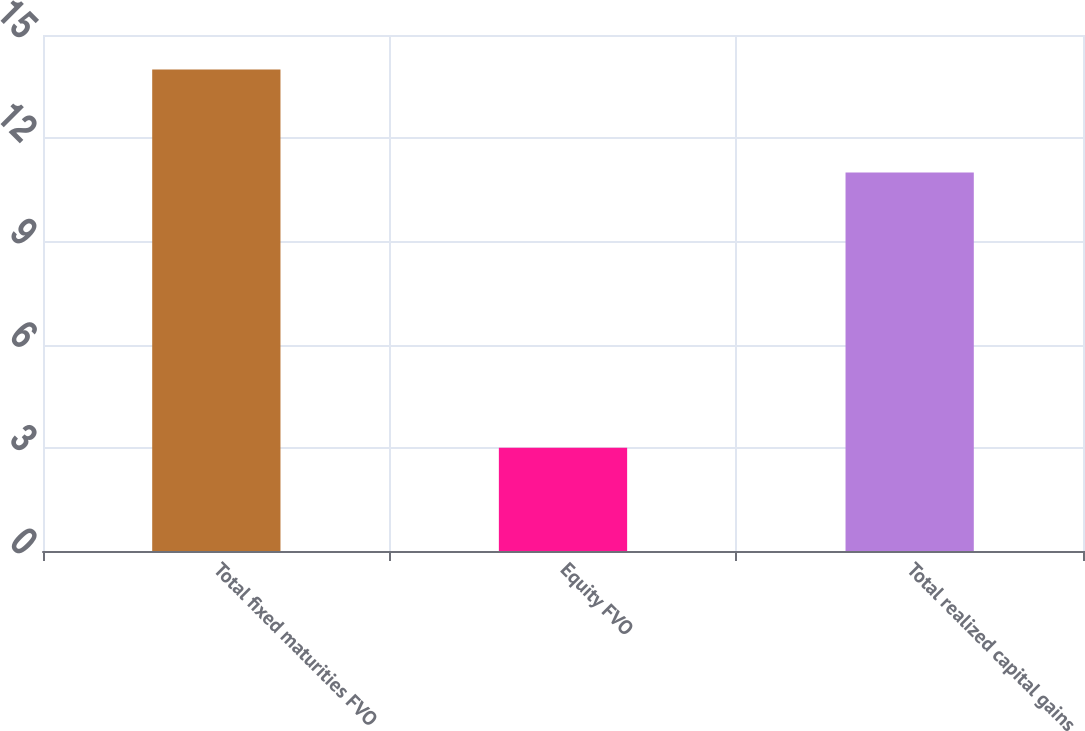<chart> <loc_0><loc_0><loc_500><loc_500><bar_chart><fcel>Total fixed maturities FVO<fcel>Equity FVO<fcel>Total realized capital gains<nl><fcel>14<fcel>3<fcel>11<nl></chart> 